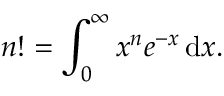Convert formula to latex. <formula><loc_0><loc_0><loc_500><loc_500>n ! = \int _ { 0 } ^ { \infty } x ^ { n } e ^ { - x } \, { d } x .</formula> 